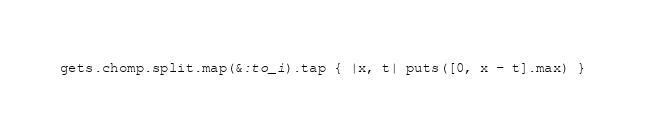Convert code to text. <code><loc_0><loc_0><loc_500><loc_500><_Ruby_>gets.chomp.split.map(&:to_i).tap { |x, t| puts([0, x - t].max) }</code> 